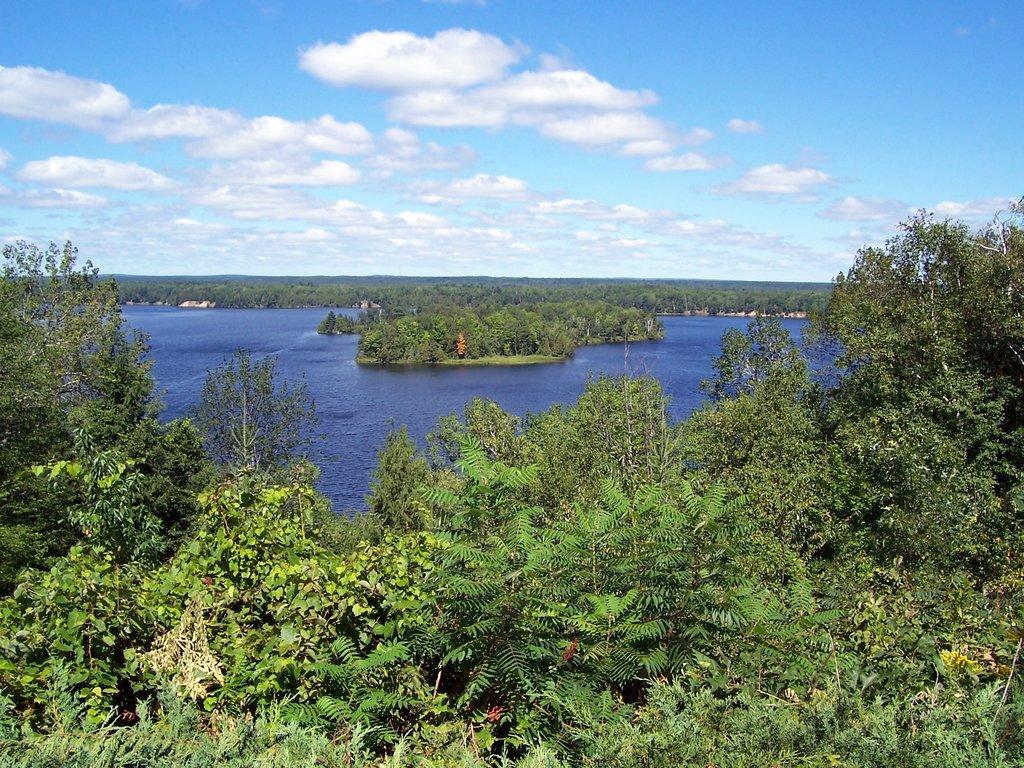Could you give a brief overview of what you see in this image? In this image we can see a group of trees and water. In the background, we can see the cloudy sky. 